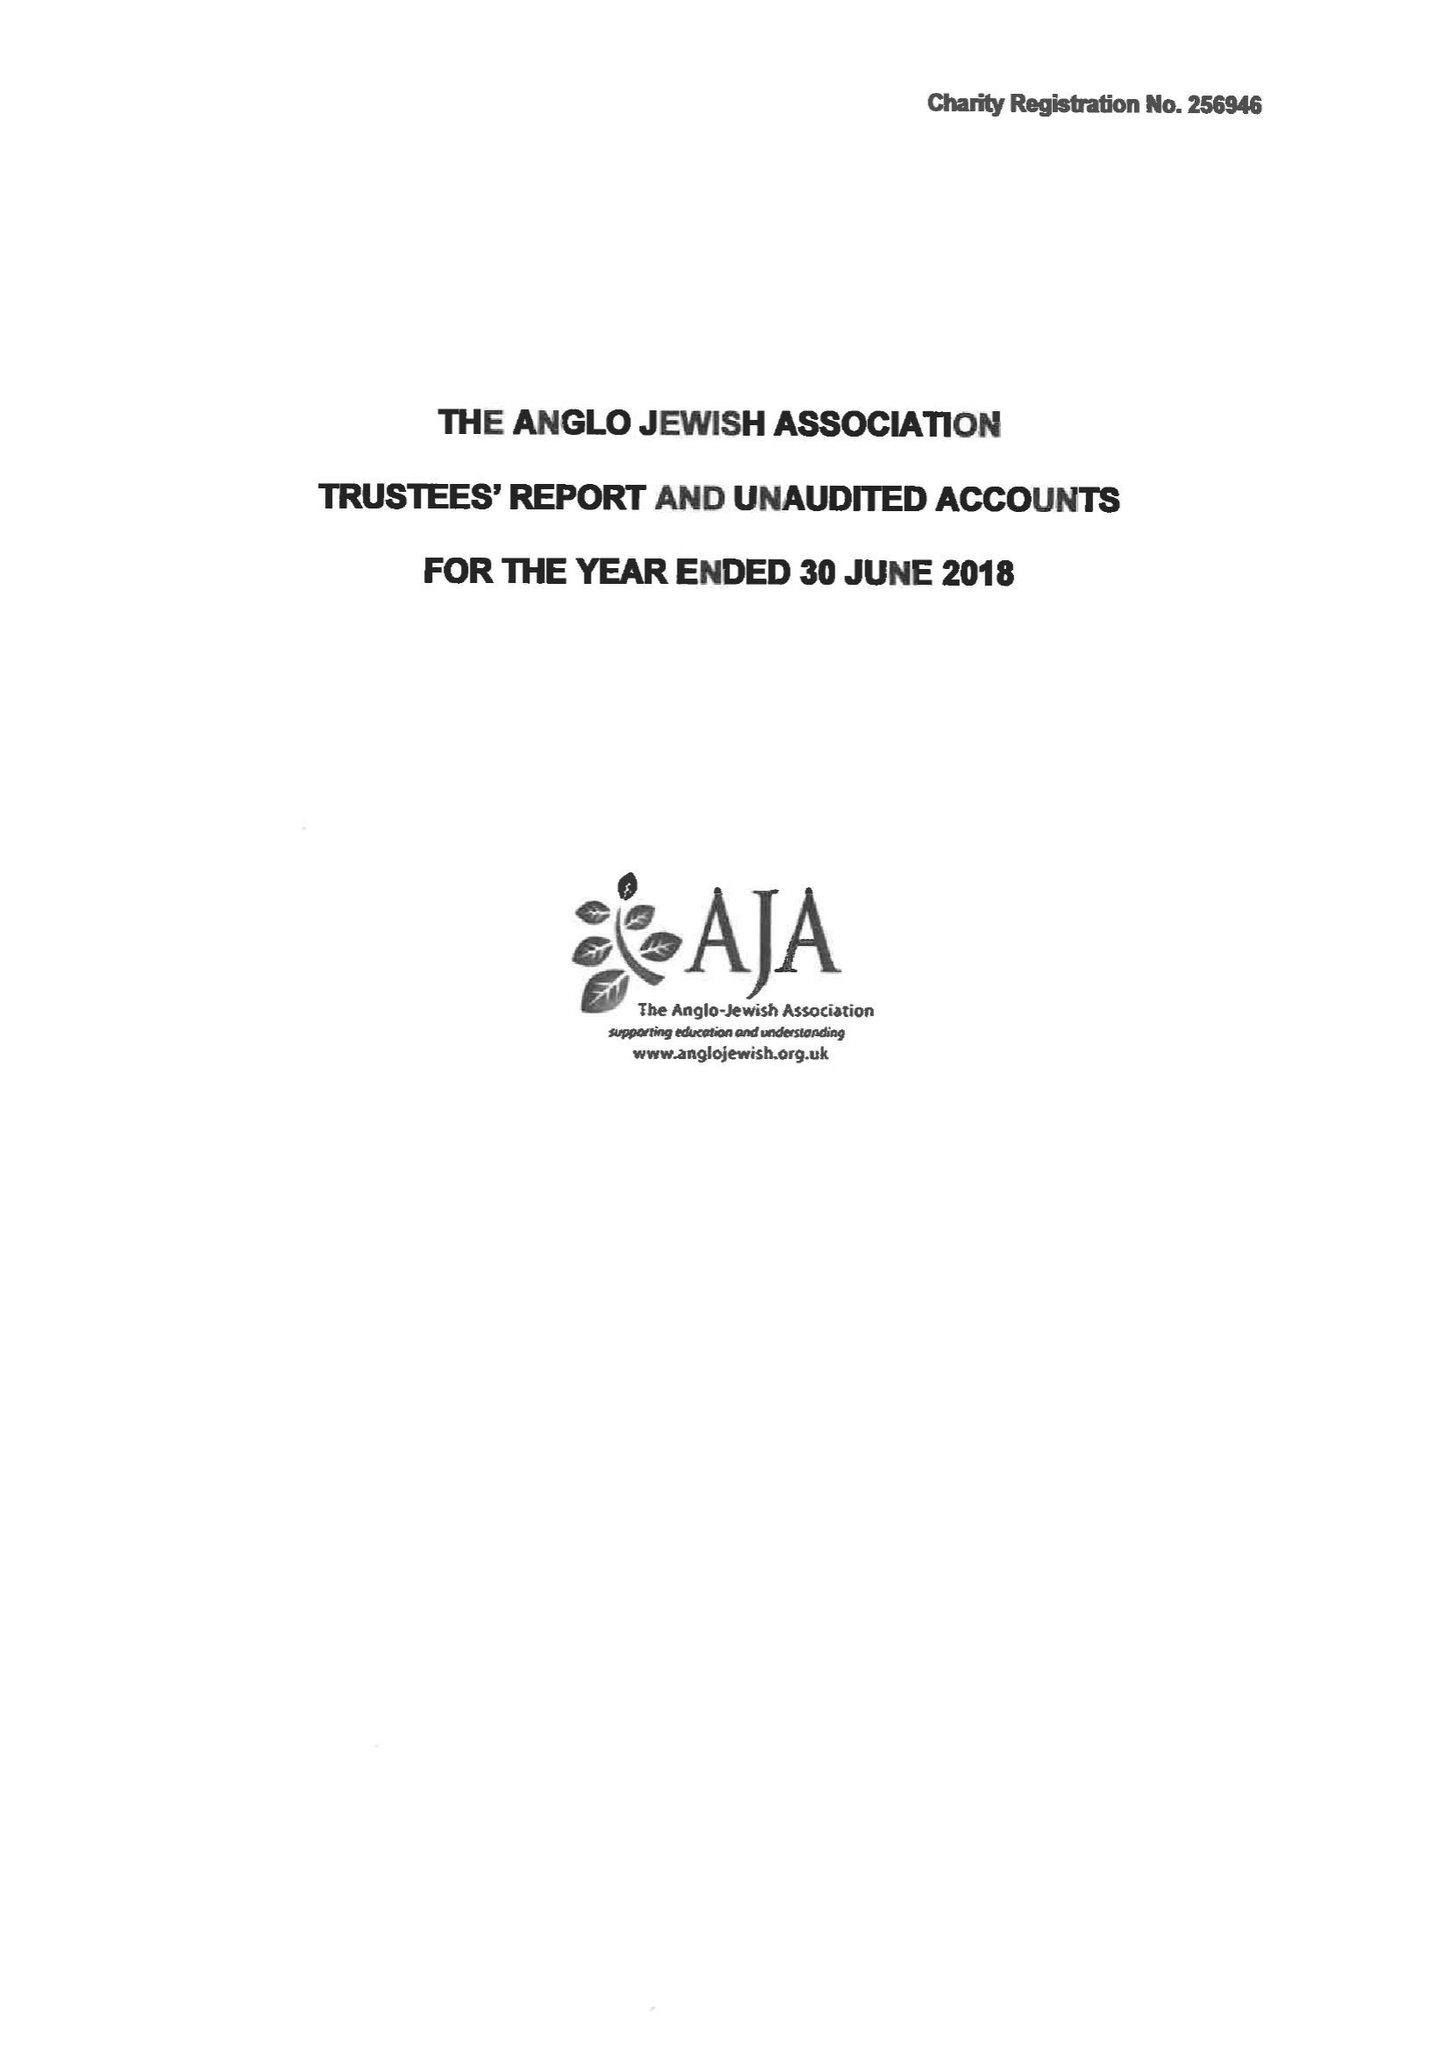What is the value for the address__post_town?
Answer the question using a single word or phrase. LONDON 